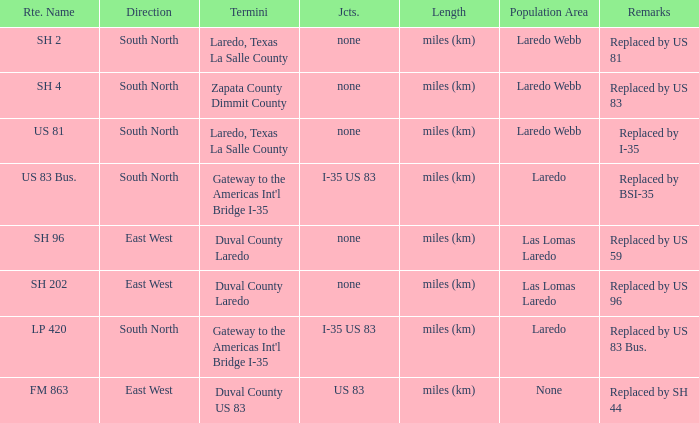Which junctions have "replaced by bsi-35" listed in their remarks section? I-35 US 83. 